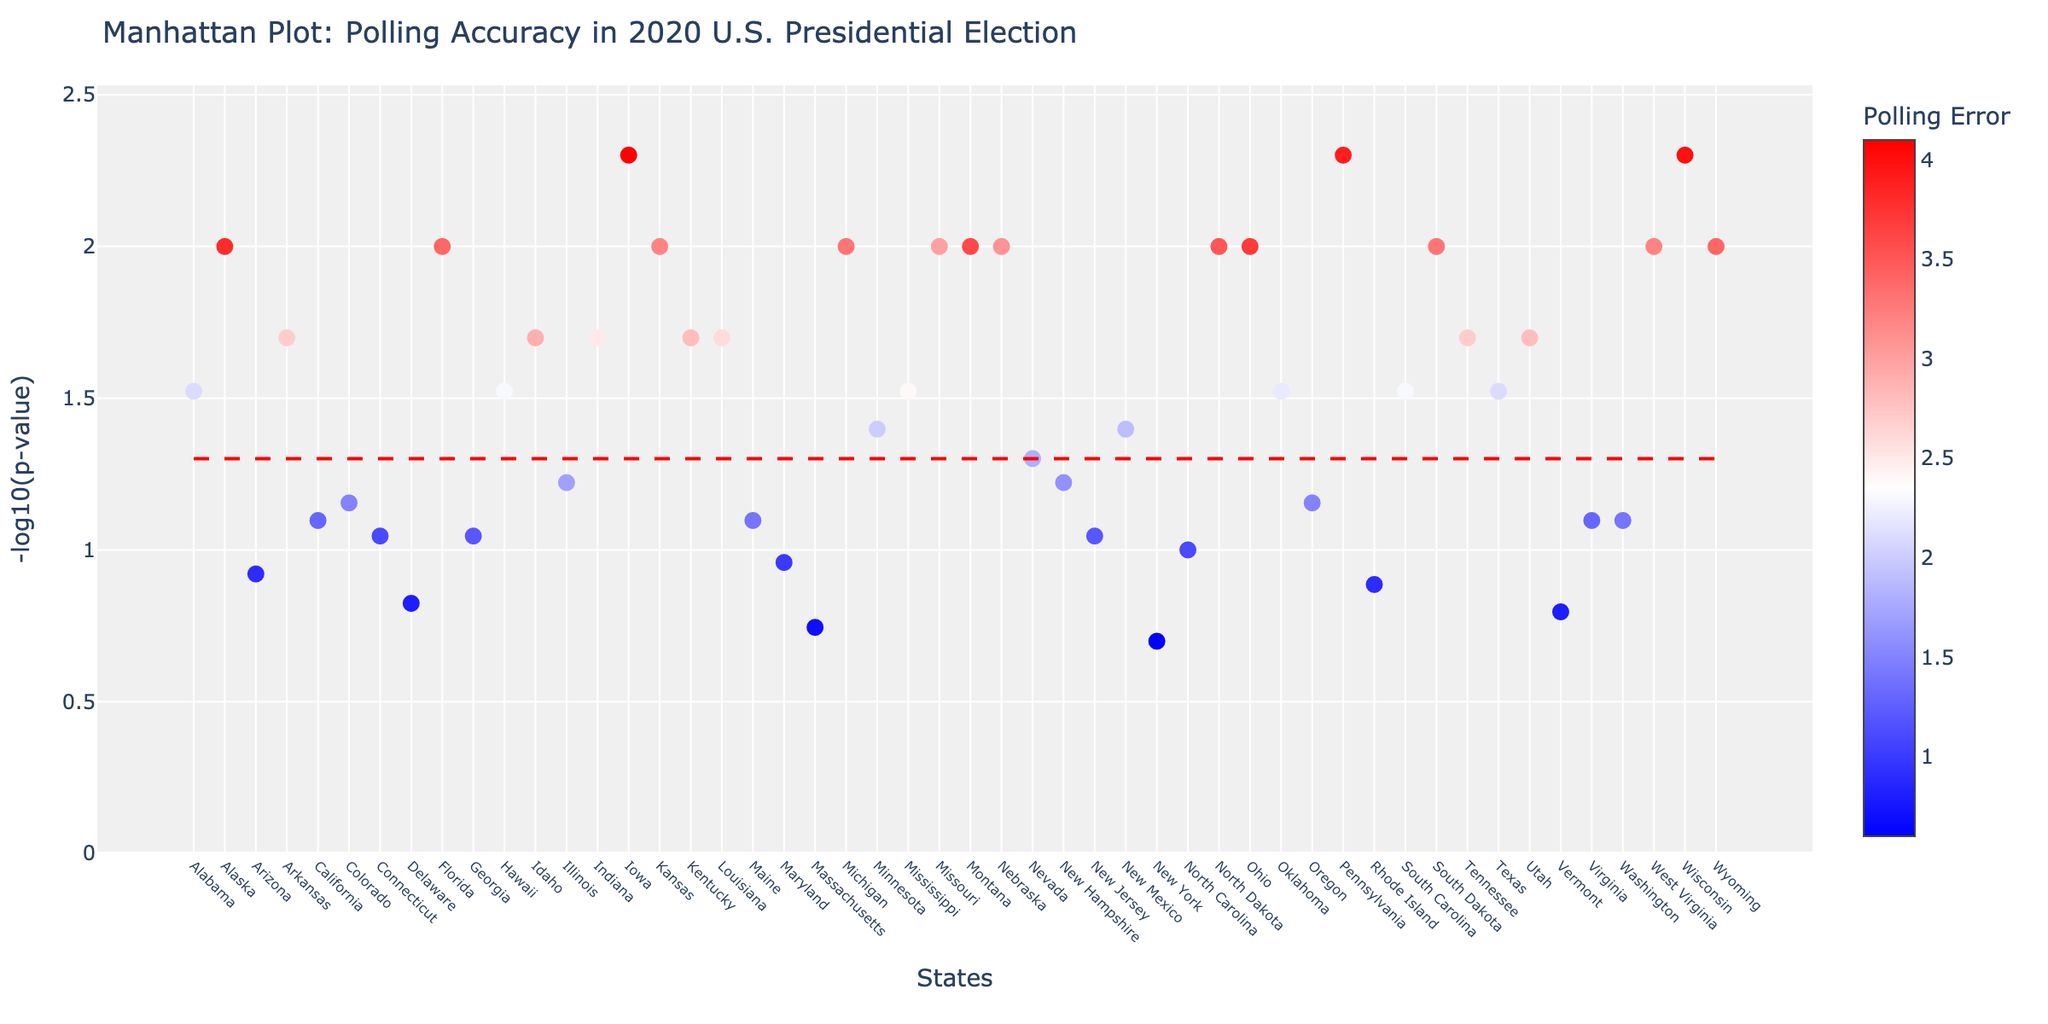What's the title of the figure? The title of any plot is usually displayed prominently at the top. In this case, the title is directly mentioned in the code generating the figure, "Manhattan Plot: Polling Accuracy in 2020 U.S. Presidential Election".
Answer: Manhattan Plot: Polling Accuracy in 2020 U.S. Presidential Election Which state has the highest polling error? The highest polling error can be identified by looking at the color scale of the markers or by hovering over each state's marker. In this case, the state with the highest polling error (4.1) is Iowa.
Answer: Iowa How many states have a p-value less than 0.01? To answer this, look for markers that are above the red dashed significance line, which represents a -log10(p-value) of 2 (since -log10(0.01) = 2). These markers signify states with p-values lower than 0.01. From the data, these states are Florida, Iowa, Pennsylvania, Wisconsin, Wyoming, South Dakota, Ohio, North Dakota, Montana, Michigan, Kansas.
Answer: 11 Which states have a p-value exactly equal to 0.01? To find this, look for the exact y-value corresponding to -log10(0.01) which is 2. By cross-referencing the states data with p-value 0.01, we get Alaska, Florida, Michigan, Missouri, Montana, Nebraska, North Dakota, Ohio, South Dakota, West Virginia, Wyoming.
Answer: 11 states Which state has the smallest -log10(p-value) and what is it? The smallest -log10(p-value) would correspond to the largest p-value. According to the data, New York has the largest p-value (0.20), so its -log10(p-value) would be -log10(0.20) ≈ 0.699.
Answer: New York, 0.699 What is the range of y-axis values displayed in the plot? The y-axis range can be determined by looking at the minimum and maximum -log10(p-value). According to the code, the range is set from 0 to 1.1 times the maximum -log10(p-value), and the maximum -log10(p-value) is from Wisconsin which is -log10(0.005) ≈ 2.301, so 2.301 * 1.1 ≈ 2.531. Therefore, the range is from 0 to 2.531.
Answer: 0 to 2.531 Which state has data points that fall exactly on the significance line? The significance line represents a y-value of -log10(0.05) which is 1.3. States with -log10(p-value) exactly 1.3 are not present in the dataset, based on direct observations. Therefore, no state's data point falls exactly on this line.
Answer: None Which states have a polling error greater than 3 but less than 4? From the dataset, states with a polling error greater than 3 but less than 4 are Alaska, Florida, Kansas, Missouri, Montana, Nebraska, North Carolina, Ohio, South Dakota, West Virginia, and Wyoming.
Answer: 10 states How is the color scale defined for the polling error in the plot? The color scale is a gradient from blue to white to red, where blue represents the lower polling errors, and red represents the higher polling errors. This color gradient helps to visually differentiate polling errors across states.
Answer: Blue to red gradient 